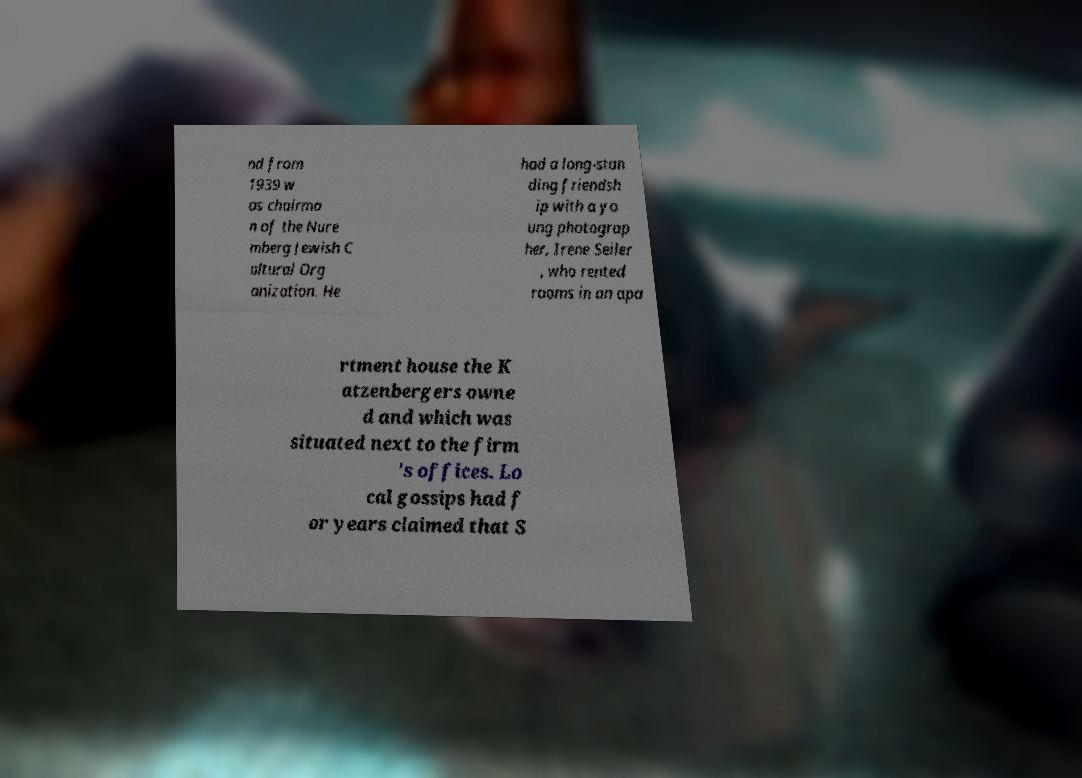There's text embedded in this image that I need extracted. Can you transcribe it verbatim? nd from 1939 w as chairma n of the Nure mberg Jewish C ultural Org anization. He had a long-stan ding friendsh ip with a yo ung photograp her, Irene Seiler , who rented rooms in an apa rtment house the K atzenbergers owne d and which was situated next to the firm 's offices. Lo cal gossips had f or years claimed that S 